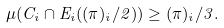Convert formula to latex. <formula><loc_0><loc_0><loc_500><loc_500>\mu ( C _ { i } \cap E _ { i } ( ( \pi ) _ { i } / 2 ) ) \geq ( \pi ) _ { i } / 3 .</formula> 